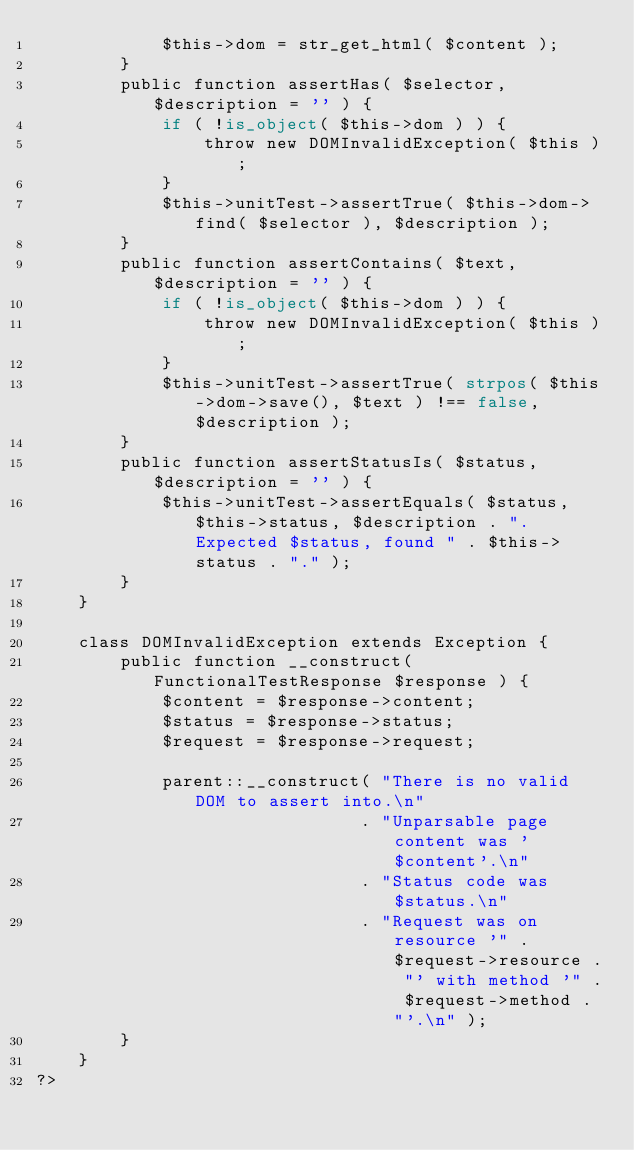<code> <loc_0><loc_0><loc_500><loc_500><_PHP_>            $this->dom = str_get_html( $content );
        }
        public function assertHas( $selector, $description = '' ) {
            if ( !is_object( $this->dom ) ) {
                throw new DOMInvalidException( $this );
            }
            $this->unitTest->assertTrue( $this->dom->find( $selector ), $description );
        }
        public function assertContains( $text, $description = '' ) {
            if ( !is_object( $this->dom ) ) {
                throw new DOMInvalidException( $this );
            }
            $this->unitTest->assertTrue( strpos( $this->dom->save(), $text ) !== false, $description );
        }
        public function assertStatusIs( $status, $description = '' ) {
            $this->unitTest->assertEquals( $status, $this->status, $description . ". Expected $status, found " . $this->status . "." );
        }
    }

    class DOMInvalidException extends Exception {
        public function __construct( FunctionalTestResponse $response ) {
            $content = $response->content;
            $status = $response->status;
            $request = $response->request;

            parent::__construct( "There is no valid DOM to assert into.\n"
                               . "Unparsable page content was '$content'.\n"
                               . "Status code was $status.\n"
                               . "Request was on resource '" . $request->resource . "' with method '" . $request->method . "'.\n" );
        }
    }
?>
</code> 